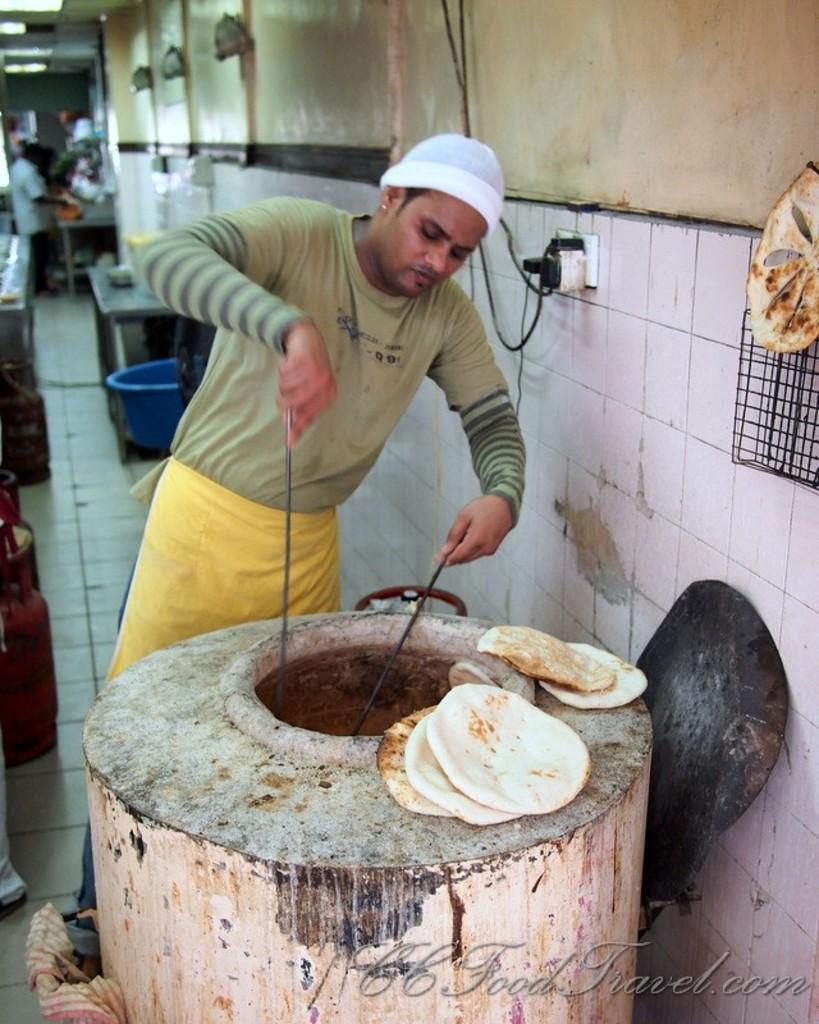How would you summarize this image in a sentence or two? In this picture I can see a man standing and holding two sticks, there is a food item, there are gas cylinders, tables, there is a tub, there is a person standing, there are lights and some other objects. 